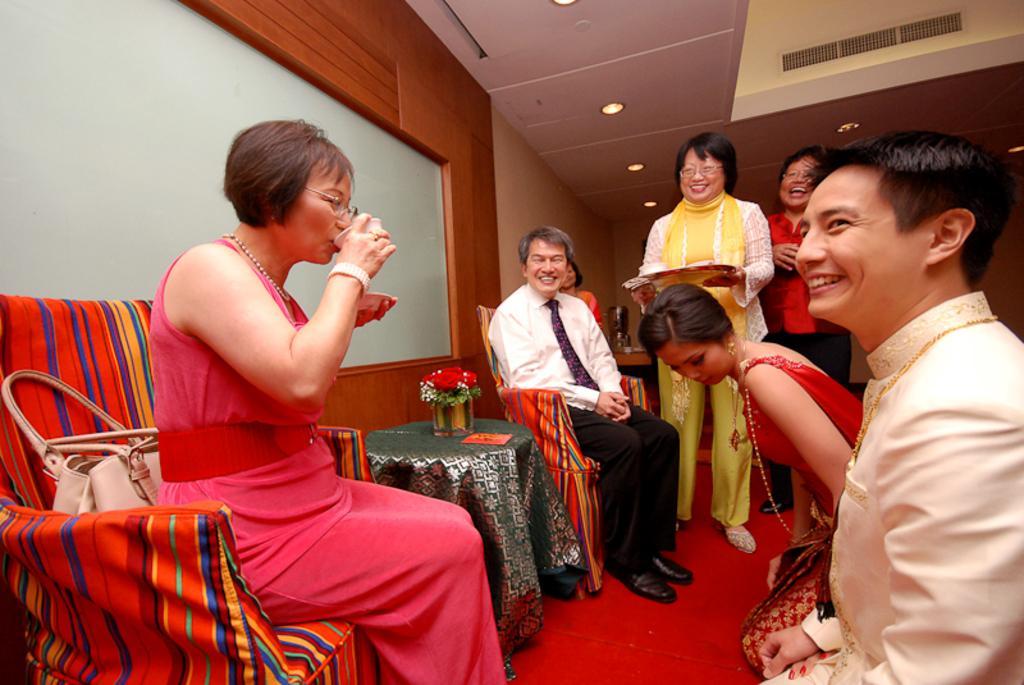Can you describe this image briefly? These two people are sitting on chairs and few people are standing. This woman holding a cup and saucer and drinking,behind this woman bag on the chair. In between these two people we can see plant and object on the table,in front of these two people there are two people sitting on knees. This woman holding a plate. In the background we can see wall and lights. 